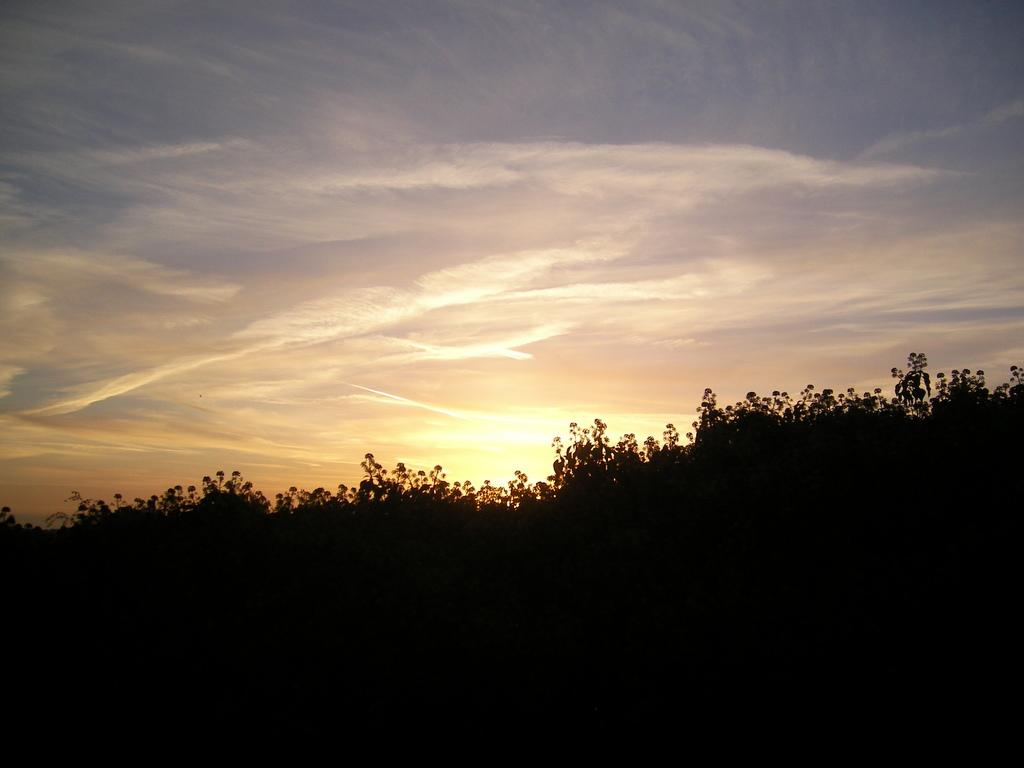What type of vegetation is visible in the image? There are many trees in the image. What can be seen in the background of the image? There are clouds and a blue sky in the background of the image. What type of sheet is being used to cast a spell in the image? There is no sheet or spell present in the image; it features trees and a blue sky in the background. 